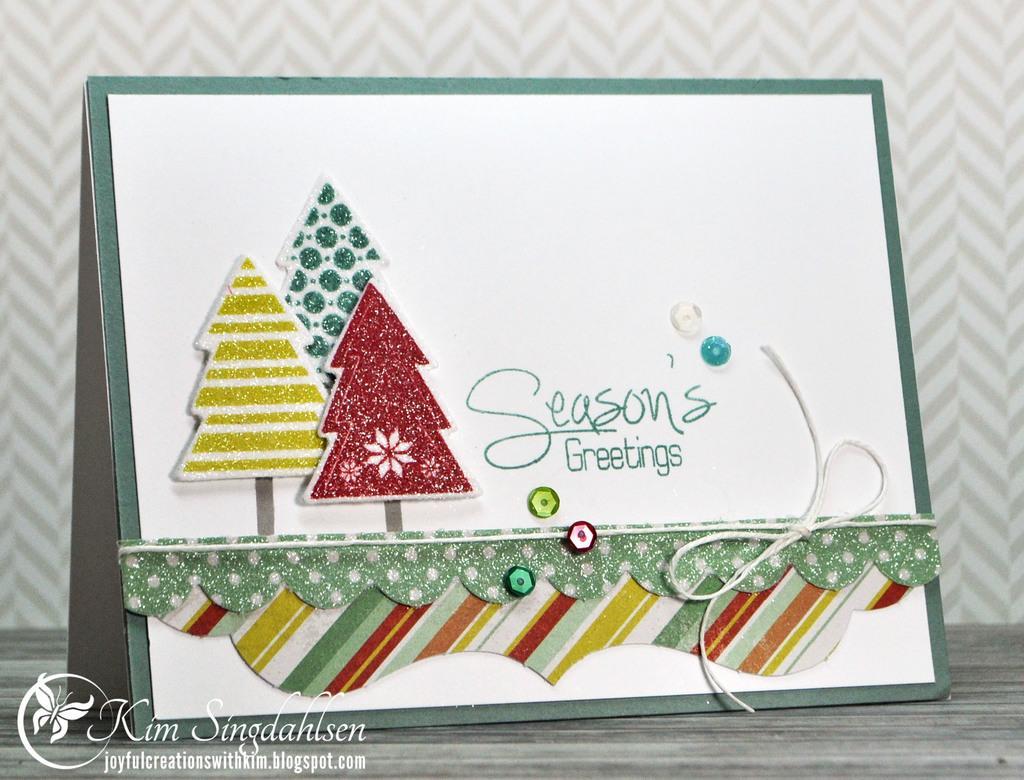Can you describe this image briefly? In this image in the middle, there is a greeting card and it is decorated. At the bottom there is a text and floor. In the background there is a wall. 